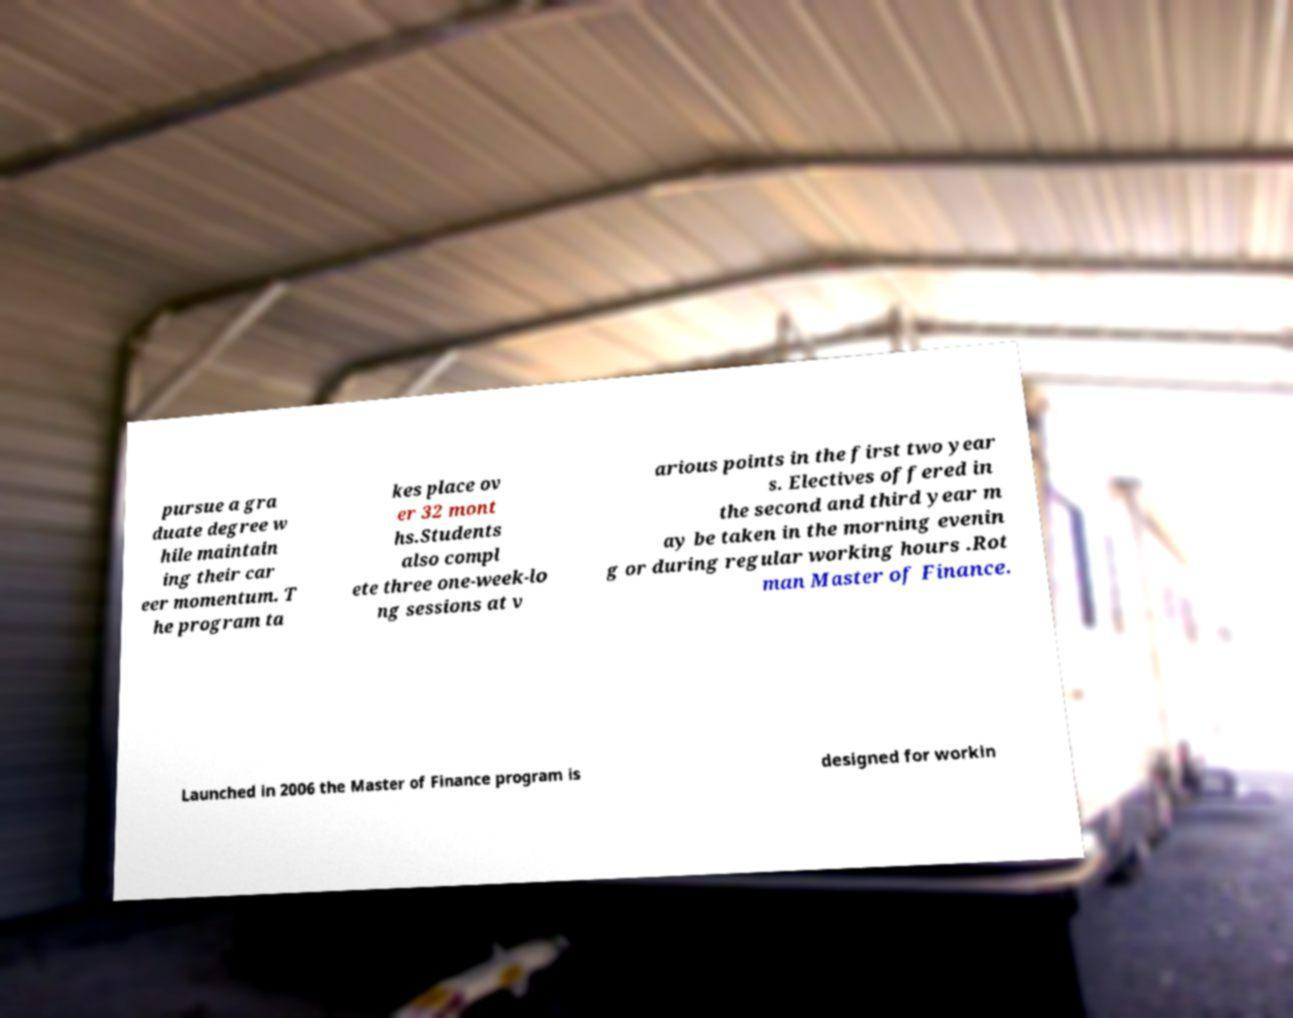Please read and relay the text visible in this image. What does it say? pursue a gra duate degree w hile maintain ing their car eer momentum. T he program ta kes place ov er 32 mont hs.Students also compl ete three one-week-lo ng sessions at v arious points in the first two year s. Electives offered in the second and third year m ay be taken in the morning evenin g or during regular working hours .Rot man Master of Finance. Launched in 2006 the Master of Finance program is designed for workin 